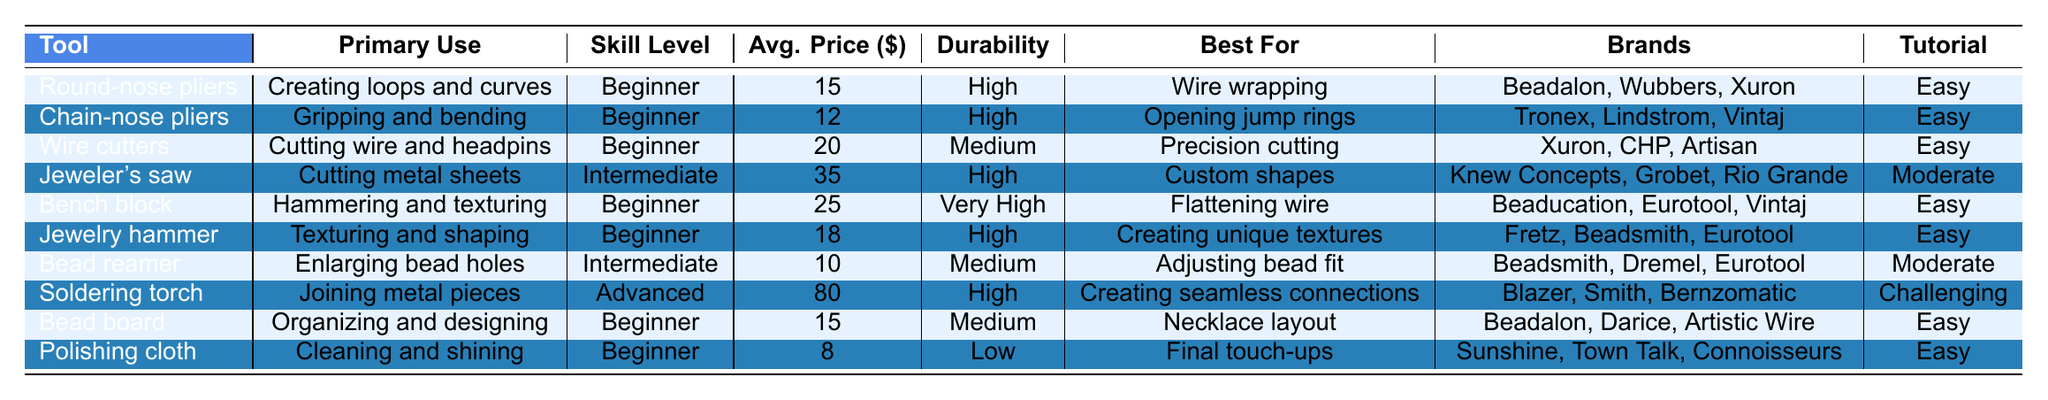What is the primary use of chain-nose pliers? The table states that the primary use of chain-nose pliers is "Gripping and bending."
Answer: Gripping and bending Which tool has the highest average price? In the table, the soldering torch has an average price of $80, which is more than the other tools listed.
Answer: Soldering torch How many tools are categorized as 'Beginner' skill level? By counting the entries, there are 6 tools listed as 'Beginner' skill level in the table.
Answer: 6 What is the best tool for creating unique textures? The jewelry hammer is specifically noted for "Creating unique textures" in the table.
Answer: Jewelry hammer Is the average price of jewelry hammers higher than wire cutters? The average price of jewelry hammers is $18, which is less than the average price of wire cutters, which is $20. Therefore, it is false.
Answer: No What is the average price of all the tools listed in the table? The average price can be calculated by summing the prices: 15 + 12 + 20 + 35 + 25 + 18 + 10 + 80 + 15 + 8 = 228 for 10 tools, so the average price is 228/10 = $22.8.
Answer: $22.8 Which tools have a durability rated as 'Medium'? The table identifies wire cutters, bead reamer, and bead board with a "Medium" durability rating.
Answer: Wire cutters, bead reamer, bead board If a beginner buys all the beginner tools, how much will they spend in total? The total cost of beginner tools (Round-nose pliers $15, Chain-nose pliers $12, Wire cutters $20, Bench block $25, Jewelry hammer $18, Bead board $15, and Polishing cloth $8) is calculated as 15 + 12 + 20 + 25 + 18 + 15 + 8 = $113.
Answer: $113 Which tool is best for enlarging bead holes and what is its average price? The bead reamer is described as the best for enlarging bead holes, with an average price of $10.
Answer: Bead reamer, $10 What are the recommended brands for the wire cutters? The table lists the brands for wire cutters as Xuron, CHP, and Artisan.
Answer: Xuron, CHP, Artisan 